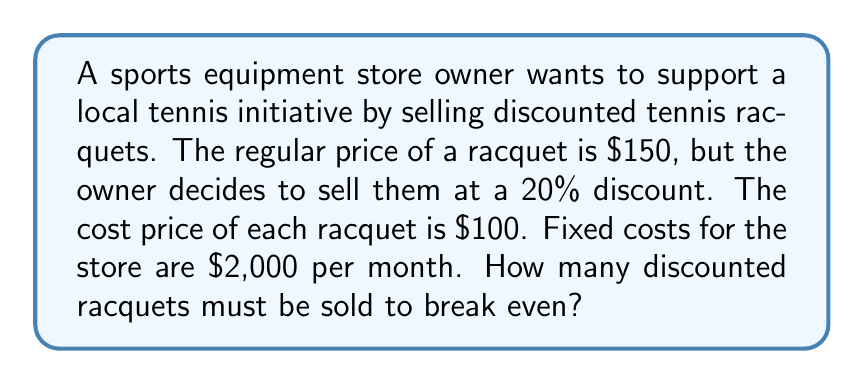Give your solution to this math problem. Let's solve this problem step by step:

1. Calculate the selling price of the discounted racquet:
   Regular price = $150
   Discount = 20% = 0.2
   Discounted price = $150 * (1 - 0.2) = $150 * 0.8 = $120

2. Calculate the profit per racquet:
   Selling price = $120
   Cost price = $100
   Profit per racquet = $120 - $100 = $20

3. Set up the break-even equation:
   Let $x$ be the number of racquets sold
   Revenue = Fixed costs + Total variable costs
   $120x = 2000 + 100x$

4. Solve the equation:
   $120x = 2000 + 100x$
   $120x - 100x = 2000$
   $20x = 2000$

5. Find the break-even point:
   $x = \frac{2000}{20} = 100$

Therefore, the store owner needs to sell 100 discounted racquets to break even.
Answer: 100 racquets 